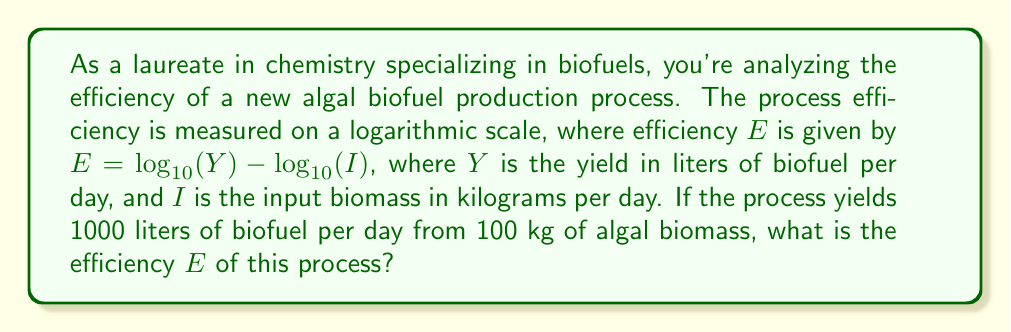Provide a solution to this math problem. To solve this problem, we'll follow these steps:

1) We're given that $E = \log_{10}(Y) - \log_{10}(I)$
   Where $Y = 1000$ liters/day and $I = 100$ kg/day

2) Let's substitute these values into the equation:
   $E = \log_{10}(1000) - \log_{10}(100)$

3) Now, let's evaluate each logarithm:
   $\log_{10}(1000) = 3$ (since $10^3 = 1000$)
   $\log_{10}(100) = 2$ (since $10^2 = 100$)

4) Substituting these values:
   $E = 3 - 2$

5) Perform the subtraction:
   $E = 1$

Therefore, the efficiency $E$ of this algal biofuel production process is 1 on the logarithmic scale.

This result indicates that the output (in liters) is 10 times the input (in kg), which is consistent with our original values of 1000 liters from 100 kg.
Answer: $E = 1$ 